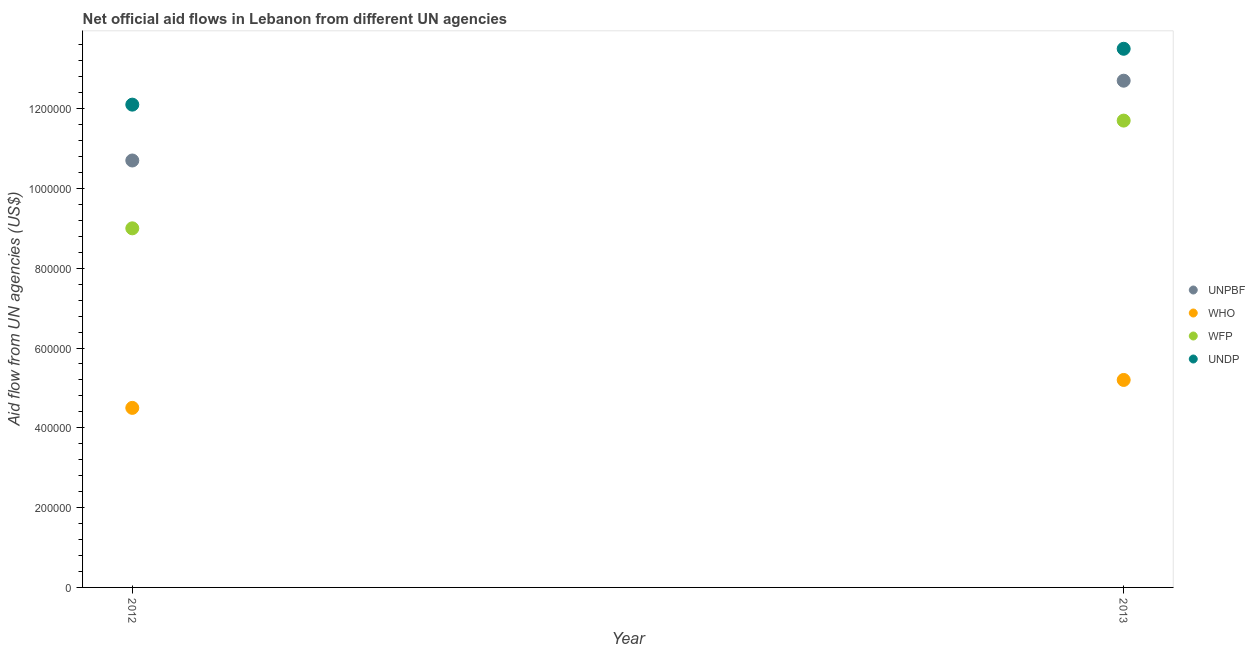Is the number of dotlines equal to the number of legend labels?
Make the answer very short. Yes. What is the amount of aid given by unpbf in 2013?
Offer a very short reply. 1.27e+06. Across all years, what is the maximum amount of aid given by who?
Offer a terse response. 5.20e+05. Across all years, what is the minimum amount of aid given by who?
Make the answer very short. 4.50e+05. What is the total amount of aid given by unpbf in the graph?
Your response must be concise. 2.34e+06. What is the difference between the amount of aid given by who in 2012 and that in 2013?
Your answer should be compact. -7.00e+04. What is the difference between the amount of aid given by undp in 2013 and the amount of aid given by who in 2012?
Make the answer very short. 9.00e+05. What is the average amount of aid given by unpbf per year?
Make the answer very short. 1.17e+06. In the year 2013, what is the difference between the amount of aid given by unpbf and amount of aid given by undp?
Ensure brevity in your answer.  -8.00e+04. What is the ratio of the amount of aid given by who in 2012 to that in 2013?
Your response must be concise. 0.87. In how many years, is the amount of aid given by undp greater than the average amount of aid given by undp taken over all years?
Ensure brevity in your answer.  1. Is it the case that in every year, the sum of the amount of aid given by unpbf and amount of aid given by who is greater than the amount of aid given by wfp?
Offer a terse response. Yes. Does the amount of aid given by undp monotonically increase over the years?
Your response must be concise. Yes. Is the amount of aid given by undp strictly greater than the amount of aid given by wfp over the years?
Keep it short and to the point. Yes. Is the amount of aid given by wfp strictly less than the amount of aid given by unpbf over the years?
Your answer should be compact. Yes. How many dotlines are there?
Offer a terse response. 4. What is the difference between two consecutive major ticks on the Y-axis?
Offer a terse response. 2.00e+05. Does the graph contain grids?
Your response must be concise. No. Where does the legend appear in the graph?
Provide a succinct answer. Center right. How are the legend labels stacked?
Your answer should be very brief. Vertical. What is the title of the graph?
Offer a very short reply. Net official aid flows in Lebanon from different UN agencies. Does "UNAIDS" appear as one of the legend labels in the graph?
Your answer should be very brief. No. What is the label or title of the Y-axis?
Ensure brevity in your answer.  Aid flow from UN agencies (US$). What is the Aid flow from UN agencies (US$) in UNPBF in 2012?
Offer a terse response. 1.07e+06. What is the Aid flow from UN agencies (US$) in WHO in 2012?
Provide a succinct answer. 4.50e+05. What is the Aid flow from UN agencies (US$) of WFP in 2012?
Provide a short and direct response. 9.00e+05. What is the Aid flow from UN agencies (US$) in UNDP in 2012?
Provide a succinct answer. 1.21e+06. What is the Aid flow from UN agencies (US$) in UNPBF in 2013?
Your answer should be compact. 1.27e+06. What is the Aid flow from UN agencies (US$) of WHO in 2013?
Provide a short and direct response. 5.20e+05. What is the Aid flow from UN agencies (US$) in WFP in 2013?
Provide a succinct answer. 1.17e+06. What is the Aid flow from UN agencies (US$) of UNDP in 2013?
Provide a short and direct response. 1.35e+06. Across all years, what is the maximum Aid flow from UN agencies (US$) of UNPBF?
Give a very brief answer. 1.27e+06. Across all years, what is the maximum Aid flow from UN agencies (US$) in WHO?
Give a very brief answer. 5.20e+05. Across all years, what is the maximum Aid flow from UN agencies (US$) in WFP?
Your answer should be very brief. 1.17e+06. Across all years, what is the maximum Aid flow from UN agencies (US$) in UNDP?
Keep it short and to the point. 1.35e+06. Across all years, what is the minimum Aid flow from UN agencies (US$) in UNPBF?
Ensure brevity in your answer.  1.07e+06. Across all years, what is the minimum Aid flow from UN agencies (US$) in WFP?
Offer a terse response. 9.00e+05. Across all years, what is the minimum Aid flow from UN agencies (US$) in UNDP?
Offer a very short reply. 1.21e+06. What is the total Aid flow from UN agencies (US$) in UNPBF in the graph?
Offer a terse response. 2.34e+06. What is the total Aid flow from UN agencies (US$) in WHO in the graph?
Offer a very short reply. 9.70e+05. What is the total Aid flow from UN agencies (US$) of WFP in the graph?
Give a very brief answer. 2.07e+06. What is the total Aid flow from UN agencies (US$) of UNDP in the graph?
Offer a very short reply. 2.56e+06. What is the difference between the Aid flow from UN agencies (US$) of UNPBF in 2012 and that in 2013?
Provide a succinct answer. -2.00e+05. What is the difference between the Aid flow from UN agencies (US$) in WHO in 2012 and that in 2013?
Provide a succinct answer. -7.00e+04. What is the difference between the Aid flow from UN agencies (US$) in UNDP in 2012 and that in 2013?
Your response must be concise. -1.40e+05. What is the difference between the Aid flow from UN agencies (US$) in UNPBF in 2012 and the Aid flow from UN agencies (US$) in WFP in 2013?
Your answer should be compact. -1.00e+05. What is the difference between the Aid flow from UN agencies (US$) in UNPBF in 2012 and the Aid flow from UN agencies (US$) in UNDP in 2013?
Give a very brief answer. -2.80e+05. What is the difference between the Aid flow from UN agencies (US$) of WHO in 2012 and the Aid flow from UN agencies (US$) of WFP in 2013?
Make the answer very short. -7.20e+05. What is the difference between the Aid flow from UN agencies (US$) of WHO in 2012 and the Aid flow from UN agencies (US$) of UNDP in 2013?
Give a very brief answer. -9.00e+05. What is the difference between the Aid flow from UN agencies (US$) in WFP in 2012 and the Aid flow from UN agencies (US$) in UNDP in 2013?
Offer a very short reply. -4.50e+05. What is the average Aid flow from UN agencies (US$) of UNPBF per year?
Make the answer very short. 1.17e+06. What is the average Aid flow from UN agencies (US$) of WHO per year?
Your response must be concise. 4.85e+05. What is the average Aid flow from UN agencies (US$) of WFP per year?
Offer a very short reply. 1.04e+06. What is the average Aid flow from UN agencies (US$) of UNDP per year?
Your answer should be compact. 1.28e+06. In the year 2012, what is the difference between the Aid flow from UN agencies (US$) in UNPBF and Aid flow from UN agencies (US$) in WHO?
Ensure brevity in your answer.  6.20e+05. In the year 2012, what is the difference between the Aid flow from UN agencies (US$) of UNPBF and Aid flow from UN agencies (US$) of UNDP?
Provide a succinct answer. -1.40e+05. In the year 2012, what is the difference between the Aid flow from UN agencies (US$) of WHO and Aid flow from UN agencies (US$) of WFP?
Make the answer very short. -4.50e+05. In the year 2012, what is the difference between the Aid flow from UN agencies (US$) of WHO and Aid flow from UN agencies (US$) of UNDP?
Provide a succinct answer. -7.60e+05. In the year 2012, what is the difference between the Aid flow from UN agencies (US$) of WFP and Aid flow from UN agencies (US$) of UNDP?
Offer a very short reply. -3.10e+05. In the year 2013, what is the difference between the Aid flow from UN agencies (US$) in UNPBF and Aid flow from UN agencies (US$) in WHO?
Offer a terse response. 7.50e+05. In the year 2013, what is the difference between the Aid flow from UN agencies (US$) in WHO and Aid flow from UN agencies (US$) in WFP?
Offer a very short reply. -6.50e+05. In the year 2013, what is the difference between the Aid flow from UN agencies (US$) in WHO and Aid flow from UN agencies (US$) in UNDP?
Offer a terse response. -8.30e+05. In the year 2013, what is the difference between the Aid flow from UN agencies (US$) of WFP and Aid flow from UN agencies (US$) of UNDP?
Make the answer very short. -1.80e+05. What is the ratio of the Aid flow from UN agencies (US$) of UNPBF in 2012 to that in 2013?
Keep it short and to the point. 0.84. What is the ratio of the Aid flow from UN agencies (US$) of WHO in 2012 to that in 2013?
Your answer should be compact. 0.87. What is the ratio of the Aid flow from UN agencies (US$) in WFP in 2012 to that in 2013?
Provide a short and direct response. 0.77. What is the ratio of the Aid flow from UN agencies (US$) in UNDP in 2012 to that in 2013?
Keep it short and to the point. 0.9. What is the difference between the highest and the second highest Aid flow from UN agencies (US$) in WHO?
Your answer should be very brief. 7.00e+04. What is the difference between the highest and the second highest Aid flow from UN agencies (US$) in UNDP?
Your answer should be compact. 1.40e+05. What is the difference between the highest and the lowest Aid flow from UN agencies (US$) in WHO?
Your response must be concise. 7.00e+04. 